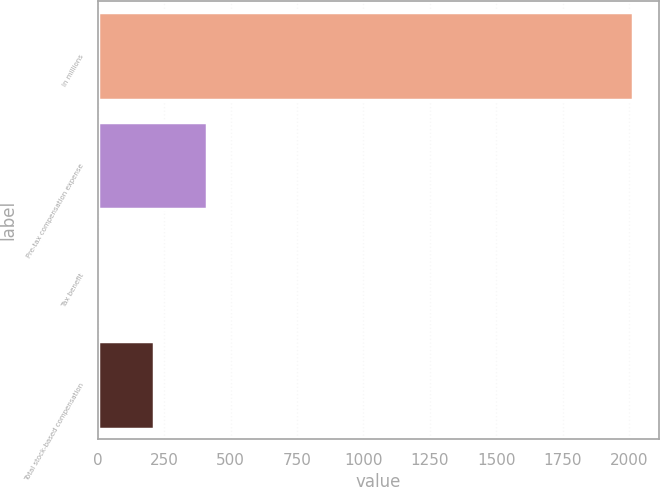Convert chart to OTSL. <chart><loc_0><loc_0><loc_500><loc_500><bar_chart><fcel>In millions<fcel>Pre-tax compensation expense<fcel>Tax benefit<fcel>Total stock-based compensation<nl><fcel>2013<fcel>410.6<fcel>10<fcel>210.3<nl></chart> 